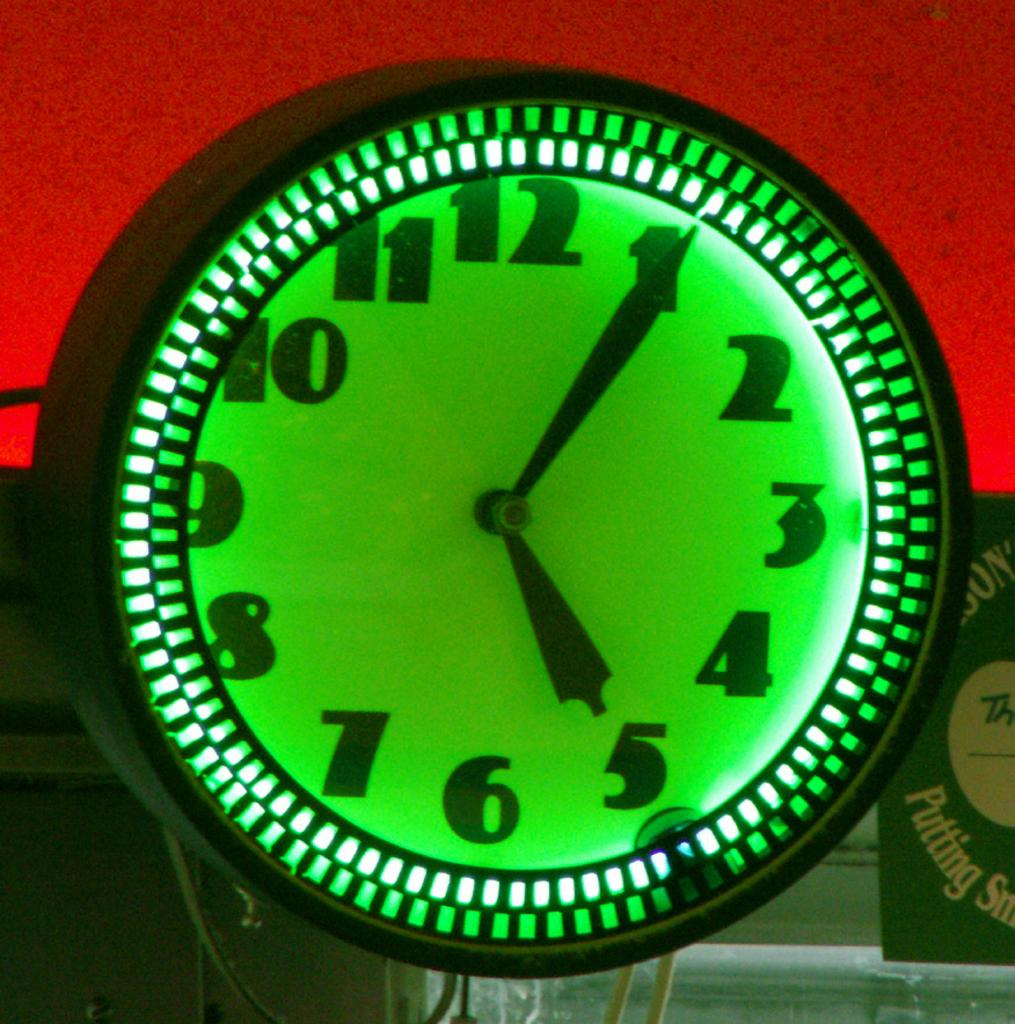What object in the image is used for measuring time? There is a clock in the image that is used for measuring time. What type of decoration is present in the image? There is a poster in the image that serves as a decoration. What type of wiring is visible in the image? There are cables in the image that indicate wiring. What can you tell me about the unspecified object in the image? Unfortunately, the facts provided do not give any details about the unspecified object in the image. What is the color of the background in the image? The background of the image is red. Can you tell me how many trains are visible in the image? There are no trains present in the image. What type of cover is used for the unspecified object in the image? Since the facts provided do not give any details about the unspecified object in the image, we cannot determine what type of cover it might have. 